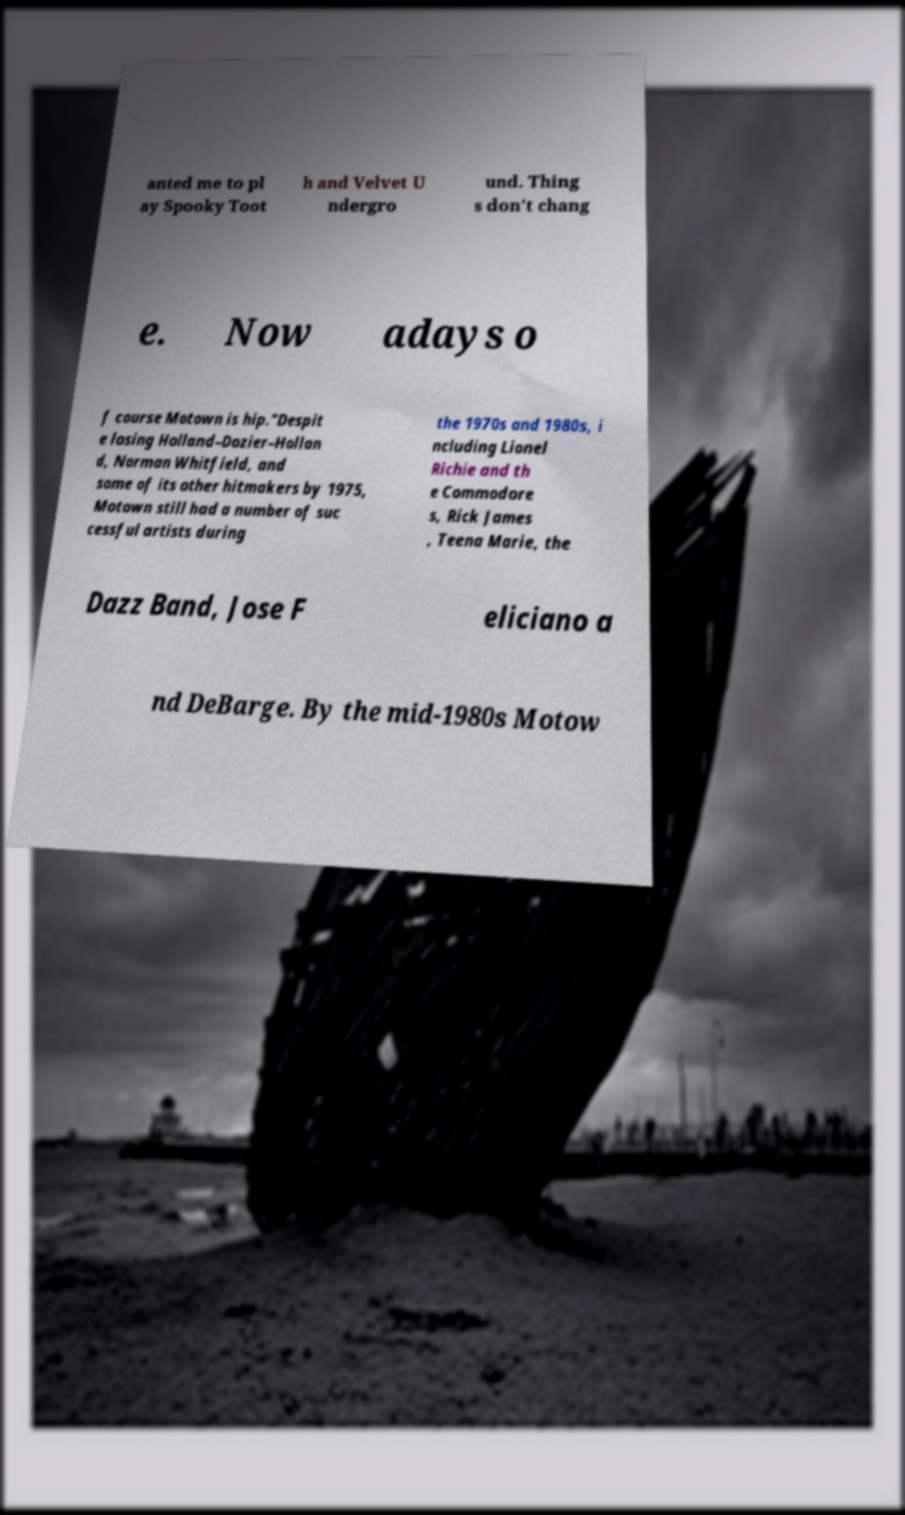For documentation purposes, I need the text within this image transcribed. Could you provide that? anted me to pl ay Spooky Toot h and Velvet U ndergro und. Thing s don't chang e. Now adays o f course Motown is hip."Despit e losing Holland–Dozier–Hollan d, Norman Whitfield, and some of its other hitmakers by 1975, Motown still had a number of suc cessful artists during the 1970s and 1980s, i ncluding Lionel Richie and th e Commodore s, Rick James , Teena Marie, the Dazz Band, Jose F eliciano a nd DeBarge. By the mid-1980s Motow 